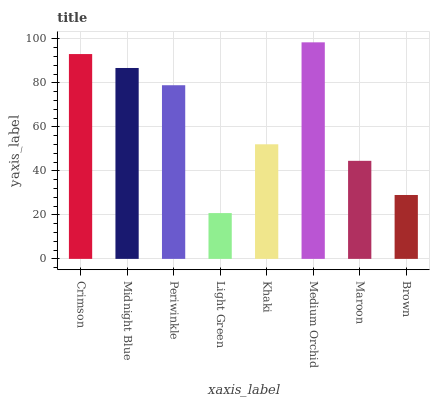Is Light Green the minimum?
Answer yes or no. Yes. Is Medium Orchid the maximum?
Answer yes or no. Yes. Is Midnight Blue the minimum?
Answer yes or no. No. Is Midnight Blue the maximum?
Answer yes or no. No. Is Crimson greater than Midnight Blue?
Answer yes or no. Yes. Is Midnight Blue less than Crimson?
Answer yes or no. Yes. Is Midnight Blue greater than Crimson?
Answer yes or no. No. Is Crimson less than Midnight Blue?
Answer yes or no. No. Is Periwinkle the high median?
Answer yes or no. Yes. Is Khaki the low median?
Answer yes or no. Yes. Is Medium Orchid the high median?
Answer yes or no. No. Is Medium Orchid the low median?
Answer yes or no. No. 